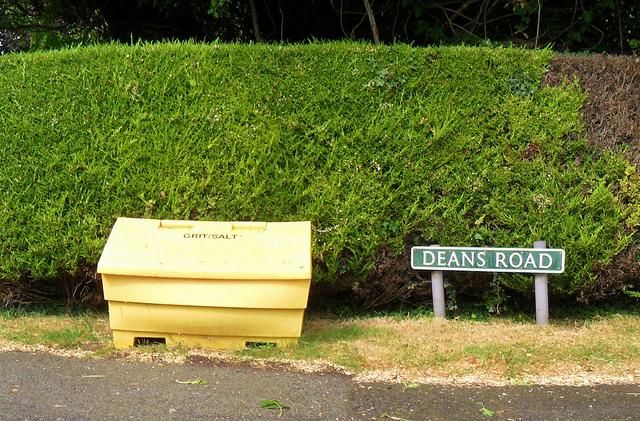What is behind the street sign?
Concise answer only. Bushes. What is the name of the road?
Give a very brief answer. Deans road. What is in the bin?
Quick response, please. Salt. 